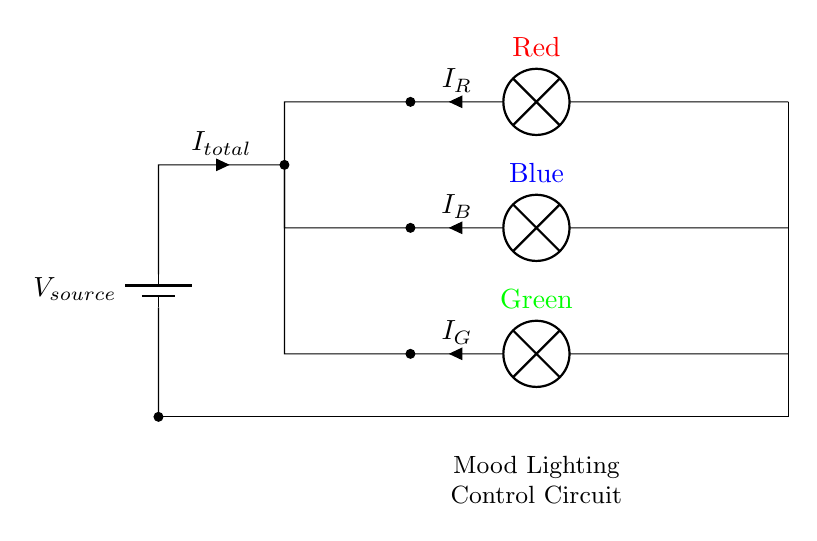What is the total current represented in the circuit? The total current is denoted as I_total, which indicates the overall current passing through the circuit from the source.
Answer: I_total How many lamps are connected in this circuit? There are three lamps connected in the circuit, each representing a different color mood lighting system.
Answer: Three What colors are represented by the lamps in the circuit? The lamps are colored red, blue, and green, as indicated by the labels next to each lamp in the diagram.
Answer: Red, blue, green What type of circuit is this? This is a parallel circuit because multiple components (lamps) are connected across the same two nodes, allowing for independent current flow through each lamp.
Answer: Parallel How does the current distribute among the lamps? The current distributes among the lamps based on their resistance; each lamp can have a different current (I_R, I_B, I_G) flowing through it.
Answer: Varies by lamp resistance What is the relationship between the voltage across all lamps? The voltage across each lamp is the same as the source voltage, because they are connected in parallel and share the same two nodes.
Answer: Same as source voltage 